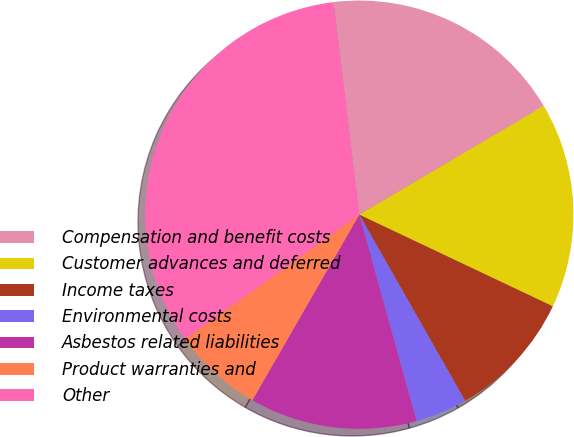Convert chart to OTSL. <chart><loc_0><loc_0><loc_500><loc_500><pie_chart><fcel>Compensation and benefit costs<fcel>Customer advances and deferred<fcel>Income taxes<fcel>Environmental costs<fcel>Asbestos related liabilities<fcel>Product warranties and<fcel>Other<nl><fcel>18.43%<fcel>15.53%<fcel>9.73%<fcel>3.92%<fcel>12.63%<fcel>6.82%<fcel>32.94%<nl></chart> 